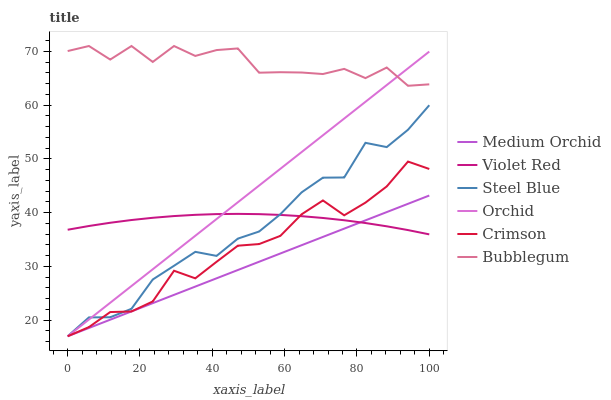Does Medium Orchid have the minimum area under the curve?
Answer yes or no. Yes. Does Bubblegum have the maximum area under the curve?
Answer yes or no. Yes. Does Steel Blue have the minimum area under the curve?
Answer yes or no. No. Does Steel Blue have the maximum area under the curve?
Answer yes or no. No. Is Orchid the smoothest?
Answer yes or no. Yes. Is Bubblegum the roughest?
Answer yes or no. Yes. Is Medium Orchid the smoothest?
Answer yes or no. No. Is Medium Orchid the roughest?
Answer yes or no. No. Does Medium Orchid have the lowest value?
Answer yes or no. Yes. Does Bubblegum have the lowest value?
Answer yes or no. No. Does Bubblegum have the highest value?
Answer yes or no. Yes. Does Medium Orchid have the highest value?
Answer yes or no. No. Is Medium Orchid less than Bubblegum?
Answer yes or no. Yes. Is Bubblegum greater than Medium Orchid?
Answer yes or no. Yes. Does Medium Orchid intersect Orchid?
Answer yes or no. Yes. Is Medium Orchid less than Orchid?
Answer yes or no. No. Is Medium Orchid greater than Orchid?
Answer yes or no. No. Does Medium Orchid intersect Bubblegum?
Answer yes or no. No. 